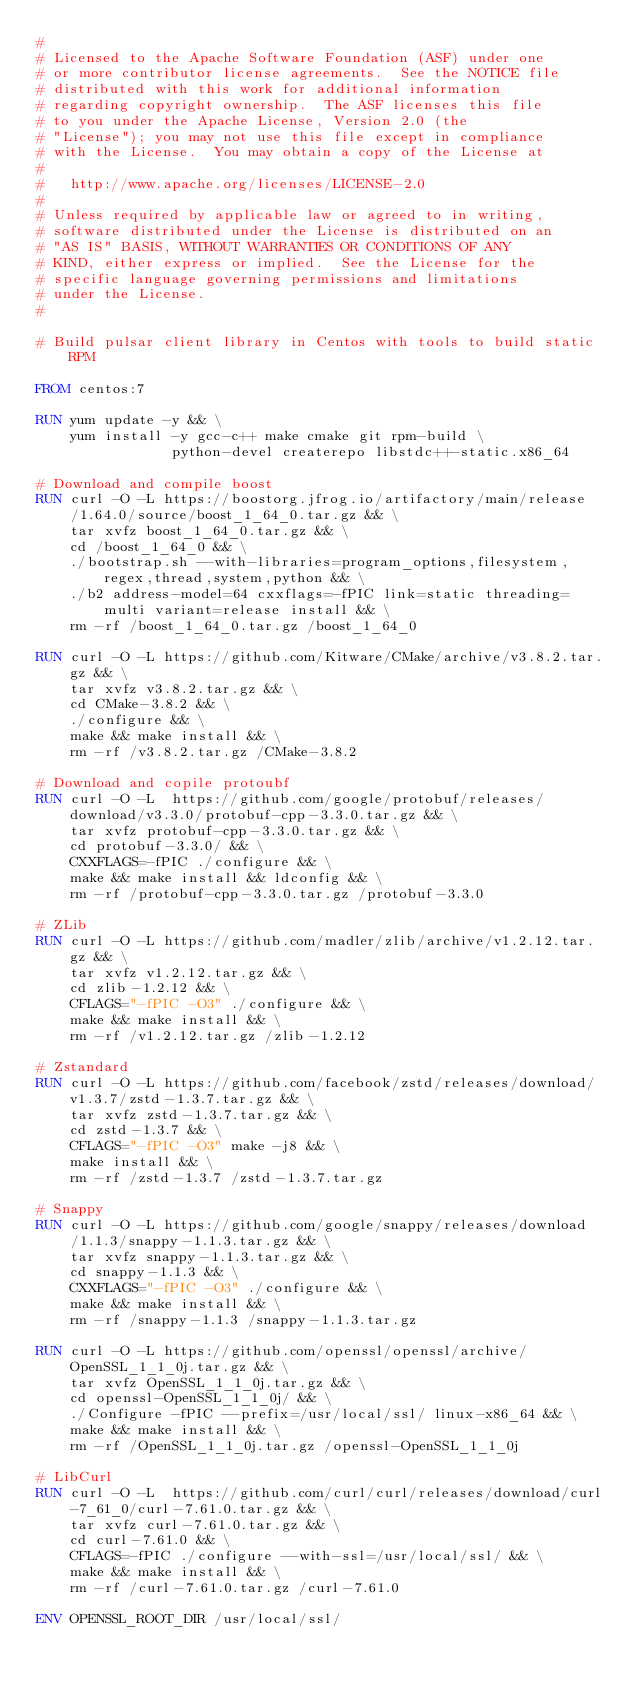Convert code to text. <code><loc_0><loc_0><loc_500><loc_500><_Dockerfile_>#
# Licensed to the Apache Software Foundation (ASF) under one
# or more contributor license agreements.  See the NOTICE file
# distributed with this work for additional information
# regarding copyright ownership.  The ASF licenses this file
# to you under the Apache License, Version 2.0 (the
# "License"); you may not use this file except in compliance
# with the License.  You may obtain a copy of the License at
#
#   http://www.apache.org/licenses/LICENSE-2.0
#
# Unless required by applicable law or agreed to in writing,
# software distributed under the License is distributed on an
# "AS IS" BASIS, WITHOUT WARRANTIES OR CONDITIONS OF ANY
# KIND, either express or implied.  See the License for the
# specific language governing permissions and limitations
# under the License.
#

# Build pulsar client library in Centos with tools to build static RPM

FROM centos:7

RUN yum update -y && \
    yum install -y gcc-c++ make cmake git rpm-build \
                python-devel createrepo libstdc++-static.x86_64

# Download and compile boost
RUN curl -O -L https://boostorg.jfrog.io/artifactory/main/release/1.64.0/source/boost_1_64_0.tar.gz && \
    tar xvfz boost_1_64_0.tar.gz && \
    cd /boost_1_64_0 && \
    ./bootstrap.sh --with-libraries=program_options,filesystem,regex,thread,system,python && \
    ./b2 address-model=64 cxxflags=-fPIC link=static threading=multi variant=release install && \
    rm -rf /boost_1_64_0.tar.gz /boost_1_64_0

RUN curl -O -L https://github.com/Kitware/CMake/archive/v3.8.2.tar.gz && \
    tar xvfz v3.8.2.tar.gz && \
    cd CMake-3.8.2 && \
    ./configure && \
    make && make install && \
    rm -rf /v3.8.2.tar.gz /CMake-3.8.2

# Download and copile protoubf
RUN curl -O -L  https://github.com/google/protobuf/releases/download/v3.3.0/protobuf-cpp-3.3.0.tar.gz && \
    tar xvfz protobuf-cpp-3.3.0.tar.gz && \
    cd protobuf-3.3.0/ && \
    CXXFLAGS=-fPIC ./configure && \
    make && make install && ldconfig && \
    rm -rf /protobuf-cpp-3.3.0.tar.gz /protobuf-3.3.0

# ZLib
RUN curl -O -L https://github.com/madler/zlib/archive/v1.2.12.tar.gz && \
    tar xvfz v1.2.12.tar.gz && \
    cd zlib-1.2.12 && \
    CFLAGS="-fPIC -O3" ./configure && \
    make && make install && \
    rm -rf /v1.2.12.tar.gz /zlib-1.2.12

# Zstandard
RUN curl -O -L https://github.com/facebook/zstd/releases/download/v1.3.7/zstd-1.3.7.tar.gz && \
    tar xvfz zstd-1.3.7.tar.gz && \
    cd zstd-1.3.7 && \
    CFLAGS="-fPIC -O3" make -j8 && \
    make install && \
    rm -rf /zstd-1.3.7 /zstd-1.3.7.tar.gz

# Snappy
RUN curl -O -L https://github.com/google/snappy/releases/download/1.1.3/snappy-1.1.3.tar.gz && \
    tar xvfz snappy-1.1.3.tar.gz && \
    cd snappy-1.1.3 && \
    CXXFLAGS="-fPIC -O3" ./configure && \
    make && make install && \
    rm -rf /snappy-1.1.3 /snappy-1.1.3.tar.gz

RUN curl -O -L https://github.com/openssl/openssl/archive/OpenSSL_1_1_0j.tar.gz && \
    tar xvfz OpenSSL_1_1_0j.tar.gz && \
    cd openssl-OpenSSL_1_1_0j/ && \
    ./Configure -fPIC --prefix=/usr/local/ssl/ linux-x86_64 && \
    make && make install && \
    rm -rf /OpenSSL_1_1_0j.tar.gz /openssl-OpenSSL_1_1_0j

# LibCurl
RUN curl -O -L  https://github.com/curl/curl/releases/download/curl-7_61_0/curl-7.61.0.tar.gz && \
    tar xvfz curl-7.61.0.tar.gz && \
    cd curl-7.61.0 && \
    CFLAGS=-fPIC ./configure --with-ssl=/usr/local/ssl/ && \
    make && make install && \
    rm -rf /curl-7.61.0.tar.gz /curl-7.61.0

ENV OPENSSL_ROOT_DIR /usr/local/ssl/
</code> 